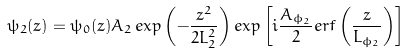<formula> <loc_0><loc_0><loc_500><loc_500>\psi _ { 2 } ( z ) = \psi _ { 0 } ( z ) A _ { 2 } \, e x p \left ( - \frac { z ^ { 2 } } { 2 L _ { 2 } ^ { 2 } } \right ) e x p \left [ i \frac { A _ { \phi _ { 2 } } } { 2 } e r f \left ( \frac { z } { L _ { \phi _ { 2 } } } \right ) \right ]</formula> 